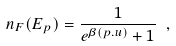Convert formula to latex. <formula><loc_0><loc_0><loc_500><loc_500>n _ { F } ( E _ { p } ) = \frac { 1 } { e ^ { \beta ( p . u ) } + 1 } \ ,</formula> 